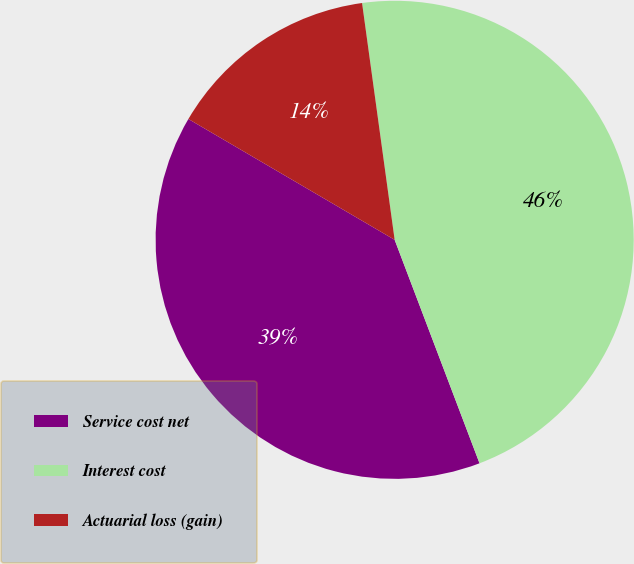Convert chart to OTSL. <chart><loc_0><loc_0><loc_500><loc_500><pie_chart><fcel>Service cost net<fcel>Interest cost<fcel>Actuarial loss (gain)<nl><fcel>39.21%<fcel>46.4%<fcel>14.39%<nl></chart> 